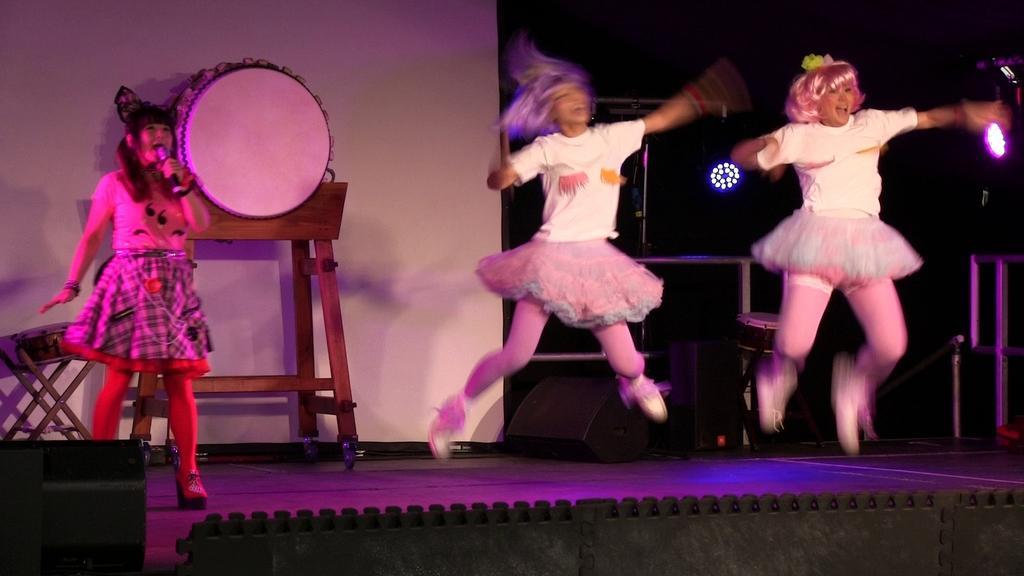Describe this image in one or two sentences. Here in this picture on the right side we can see two women jumping on a stage and on the left side we can see a woman standing and singing the song in the microphone present in her hand and behind her we can see a drum present on a table over there and we can also see different lights present over there. 